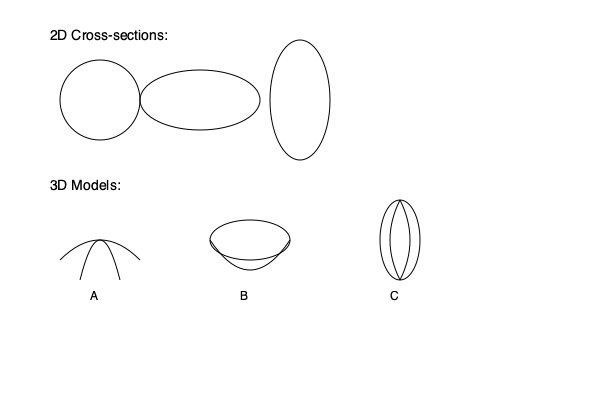Based on the given 2D cross-sections of a plant's root system, which 3D model (A, B, or C) most accurately represents the complete root structure? To determine the correct 3D model, we need to analyze the 2D cross-sections and compare them with the potential 3D representations:

1. Observe the 2D cross-sections:
   - Left: Circular shape
   - Middle: Horizontally elongated ellipse
   - Right: Vertically elongated ellipse

2. Analyze the 3D models:
   - Model A: Shows a taproot system with lateral roots spreading outwards
   - Model B: Depicts a horizontally spread root system
   - Model C: Illustrates a vertically oriented root system with some horizontal spread

3. Compare the cross-sections with the 3D models:
   - The circular cross-section could represent a horizontal slice through Model C
   - The horizontally elongated ellipse matches a vertical slice through Model B
   - The vertically elongated ellipse corresponds to a vertical slice through Model C

4. Evaluate which model satisfies all cross-sections:
   - Model A doesn't match any of the given cross-sections
   - Model B matches only the horizontally elongated ellipse
   - Model C can produce all three cross-sections depending on the angle of the slice

5. Conclusion:
   Model C is the only 3D representation that can account for all three 2D cross-sections. It shows a vertically oriented root system that, when sliced horizontally, would produce a circular cross-section, and when sliced vertically at different angles, could produce both horizontally and vertically elongated ellipses.
Answer: C 